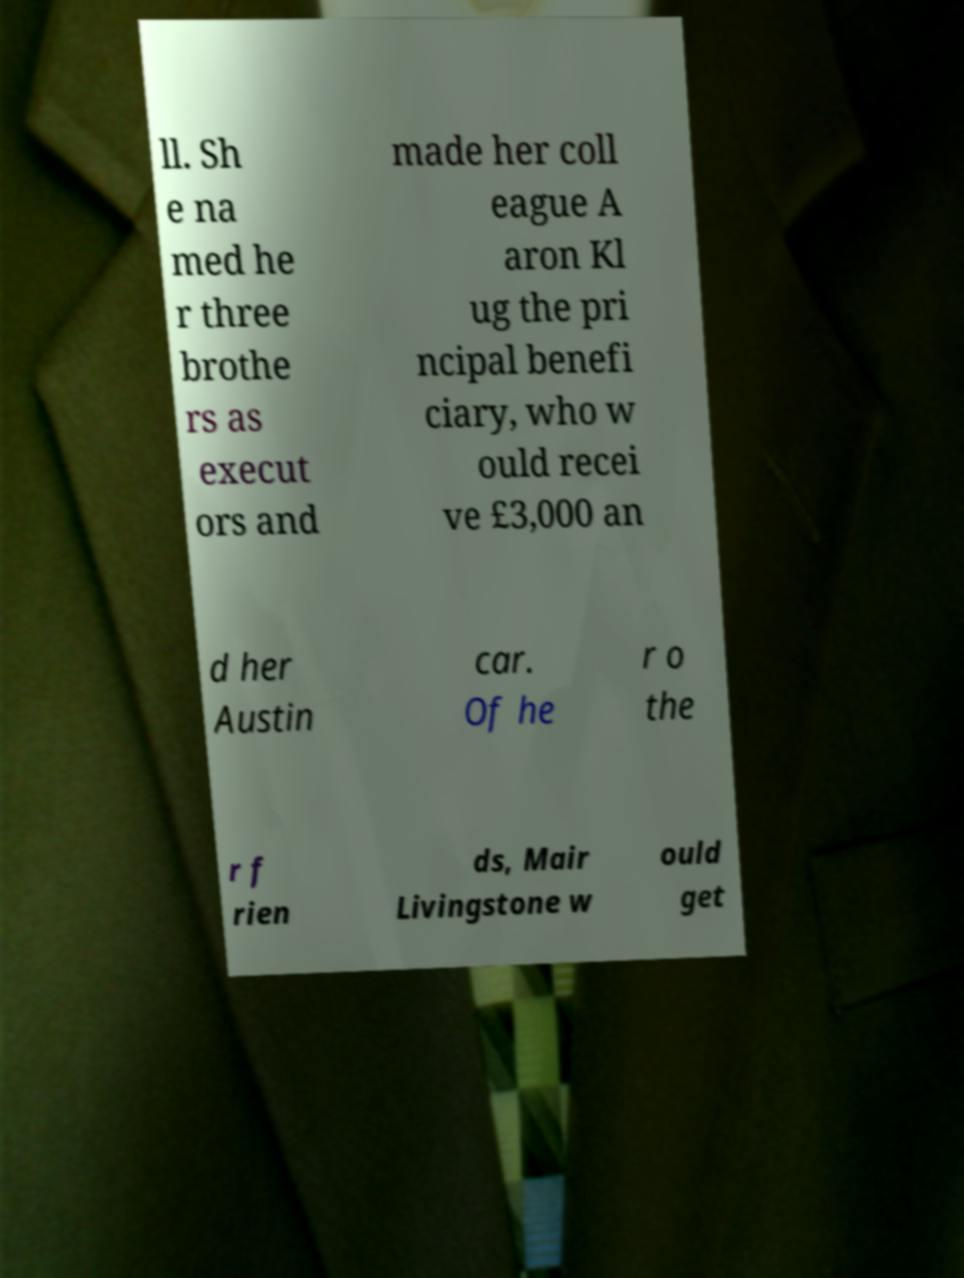Can you accurately transcribe the text from the provided image for me? ll. Sh e na med he r three brothe rs as execut ors and made her coll eague A aron Kl ug the pri ncipal benefi ciary, who w ould recei ve £3,000 an d her Austin car. Of he r o the r f rien ds, Mair Livingstone w ould get 